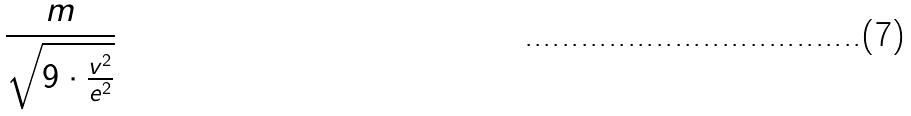Convert formula to latex. <formula><loc_0><loc_0><loc_500><loc_500>\frac { m } { \sqrt { 9 \cdot \frac { v ^ { 2 } } { e ^ { 2 } } } }</formula> 